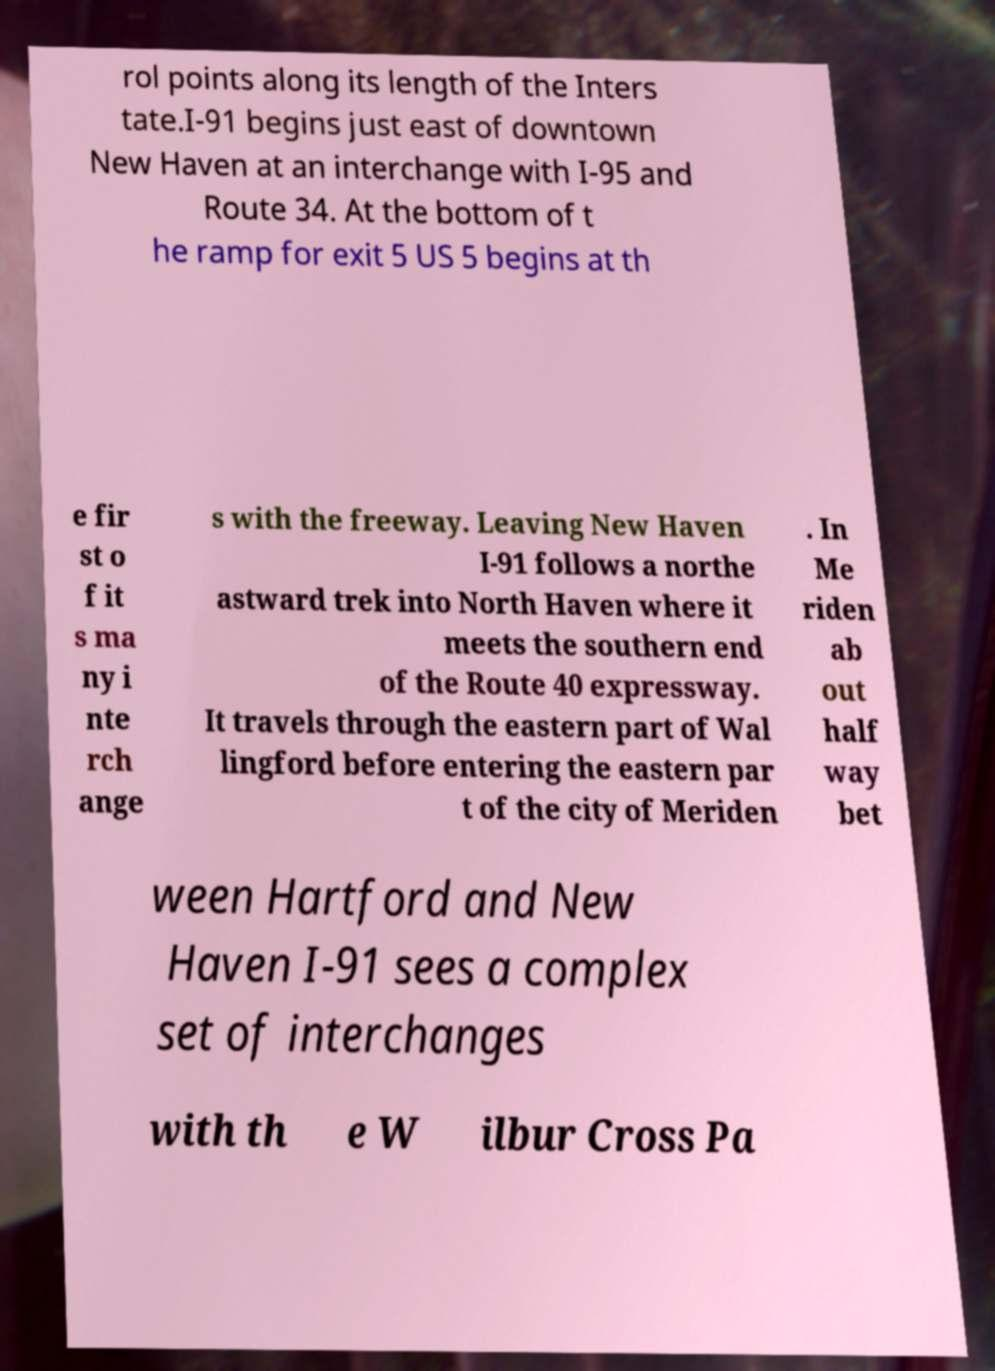For documentation purposes, I need the text within this image transcribed. Could you provide that? rol points along its length of the Inters tate.I-91 begins just east of downtown New Haven at an interchange with I-95 and Route 34. At the bottom of t he ramp for exit 5 US 5 begins at th e fir st o f it s ma ny i nte rch ange s with the freeway. Leaving New Haven I-91 follows a northe astward trek into North Haven where it meets the southern end of the Route 40 expressway. It travels through the eastern part of Wal lingford before entering the eastern par t of the city of Meriden . In Me riden ab out half way bet ween Hartford and New Haven I-91 sees a complex set of interchanges with th e W ilbur Cross Pa 